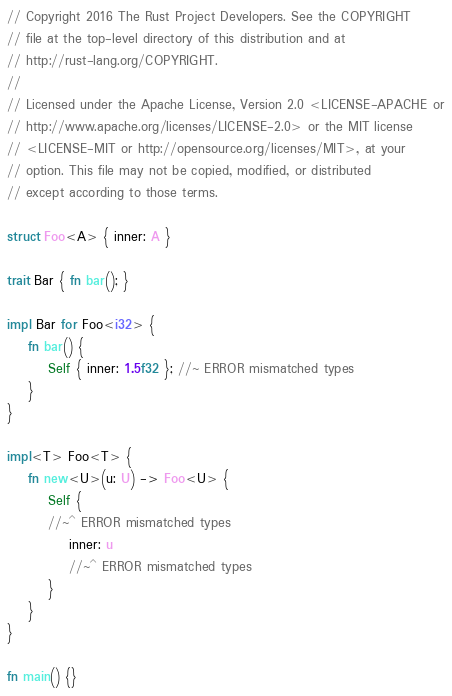Convert code to text. <code><loc_0><loc_0><loc_500><loc_500><_Rust_>// Copyright 2016 The Rust Project Developers. See the COPYRIGHT
// file at the top-level directory of this distribution and at
// http://rust-lang.org/COPYRIGHT.
//
// Licensed under the Apache License, Version 2.0 <LICENSE-APACHE or
// http://www.apache.org/licenses/LICENSE-2.0> or the MIT license
// <LICENSE-MIT or http://opensource.org/licenses/MIT>, at your
// option. This file may not be copied, modified, or distributed
// except according to those terms.

struct Foo<A> { inner: A }

trait Bar { fn bar(); }

impl Bar for Foo<i32> {
    fn bar() {
        Self { inner: 1.5f32 }; //~ ERROR mismatched types
    }
}

impl<T> Foo<T> {
    fn new<U>(u: U) -> Foo<U> {
        Self {
        //~^ ERROR mismatched types
            inner: u
            //~^ ERROR mismatched types
        }
    }
}

fn main() {}
</code> 